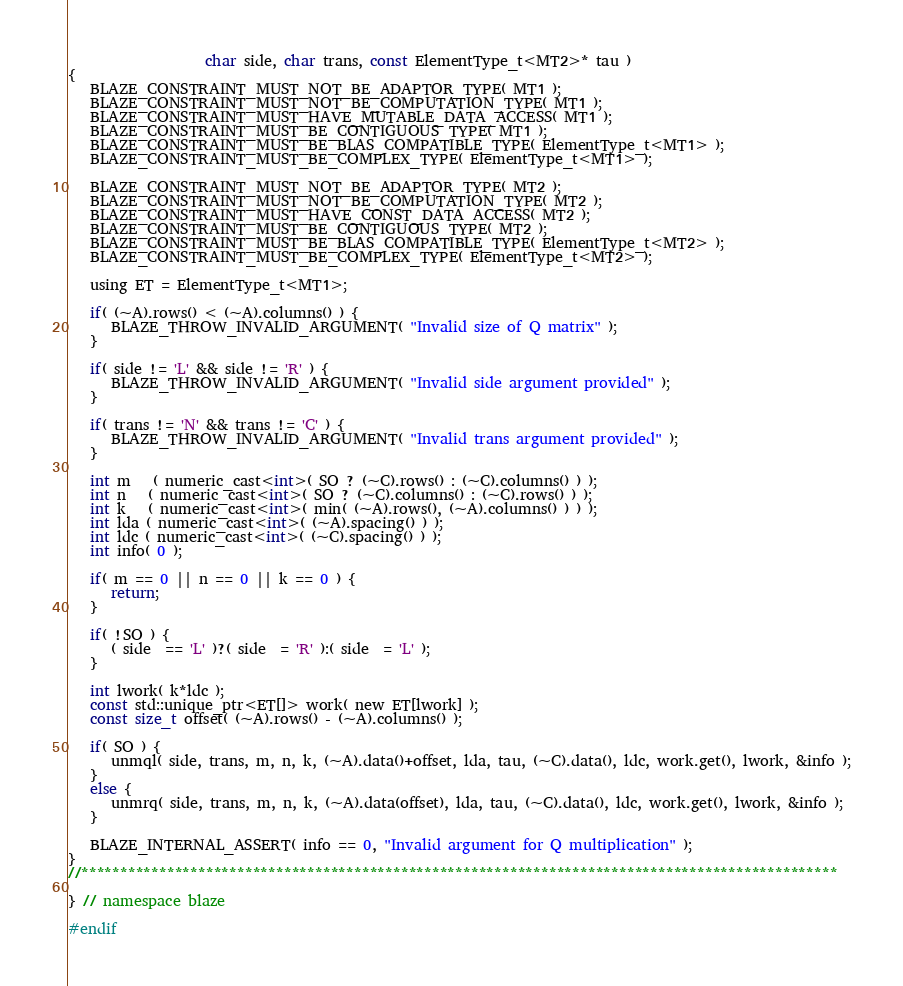Convert code to text. <code><loc_0><loc_0><loc_500><loc_500><_C_>                   char side, char trans, const ElementType_t<MT2>* tau )
{
   BLAZE_CONSTRAINT_MUST_NOT_BE_ADAPTOR_TYPE( MT1 );
   BLAZE_CONSTRAINT_MUST_NOT_BE_COMPUTATION_TYPE( MT1 );
   BLAZE_CONSTRAINT_MUST_HAVE_MUTABLE_DATA_ACCESS( MT1 );
   BLAZE_CONSTRAINT_MUST_BE_CONTIGUOUS_TYPE( MT1 );
   BLAZE_CONSTRAINT_MUST_BE_BLAS_COMPATIBLE_TYPE( ElementType_t<MT1> );
   BLAZE_CONSTRAINT_MUST_BE_COMPLEX_TYPE( ElementType_t<MT1> );

   BLAZE_CONSTRAINT_MUST_NOT_BE_ADAPTOR_TYPE( MT2 );
   BLAZE_CONSTRAINT_MUST_NOT_BE_COMPUTATION_TYPE( MT2 );
   BLAZE_CONSTRAINT_MUST_HAVE_CONST_DATA_ACCESS( MT2 );
   BLAZE_CONSTRAINT_MUST_BE_CONTIGUOUS_TYPE( MT2 );
   BLAZE_CONSTRAINT_MUST_BE_BLAS_COMPATIBLE_TYPE( ElementType_t<MT2> );
   BLAZE_CONSTRAINT_MUST_BE_COMPLEX_TYPE( ElementType_t<MT2> );

   using ET = ElementType_t<MT1>;

   if( (~A).rows() < (~A).columns() ) {
      BLAZE_THROW_INVALID_ARGUMENT( "Invalid size of Q matrix" );
   }

   if( side != 'L' && side != 'R' ) {
      BLAZE_THROW_INVALID_ARGUMENT( "Invalid side argument provided" );
   }

   if( trans != 'N' && trans != 'C' ) {
      BLAZE_THROW_INVALID_ARGUMENT( "Invalid trans argument provided" );
   }

   int m   ( numeric_cast<int>( SO ? (~C).rows() : (~C).columns() ) );
   int n   ( numeric_cast<int>( SO ? (~C).columns() : (~C).rows() ) );
   int k   ( numeric_cast<int>( min( (~A).rows(), (~A).columns() ) ) );
   int lda ( numeric_cast<int>( (~A).spacing() ) );
   int ldc ( numeric_cast<int>( (~C).spacing() ) );
   int info( 0 );

   if( m == 0 || n == 0 || k == 0 ) {
      return;
   }

   if( !SO ) {
      ( side  == 'L' )?( side  = 'R' ):( side  = 'L' );
   }

   int lwork( k*ldc );
   const std::unique_ptr<ET[]> work( new ET[lwork] );
   const size_t offset( (~A).rows() - (~A).columns() );

   if( SO ) {
      unmql( side, trans, m, n, k, (~A).data()+offset, lda, tau, (~C).data(), ldc, work.get(), lwork, &info );
   }
   else {
      unmrq( side, trans, m, n, k, (~A).data(offset), lda, tau, (~C).data(), ldc, work.get(), lwork, &info );
   }

   BLAZE_INTERNAL_ASSERT( info == 0, "Invalid argument for Q multiplication" );
}
//*************************************************************************************************

} // namespace blaze

#endif
</code> 